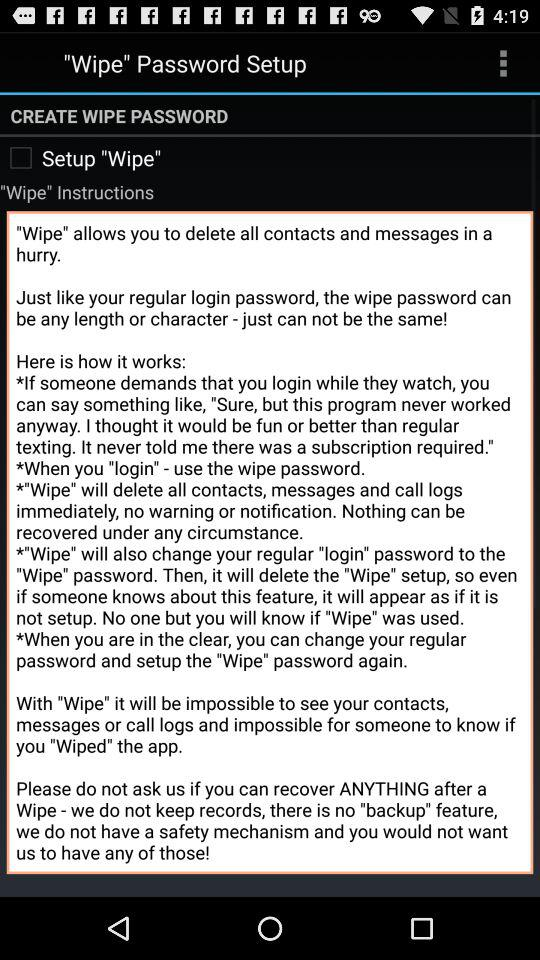What does "Wipe" allow? "Wipe" allows you to delete all contacts and messages in a hurry. 